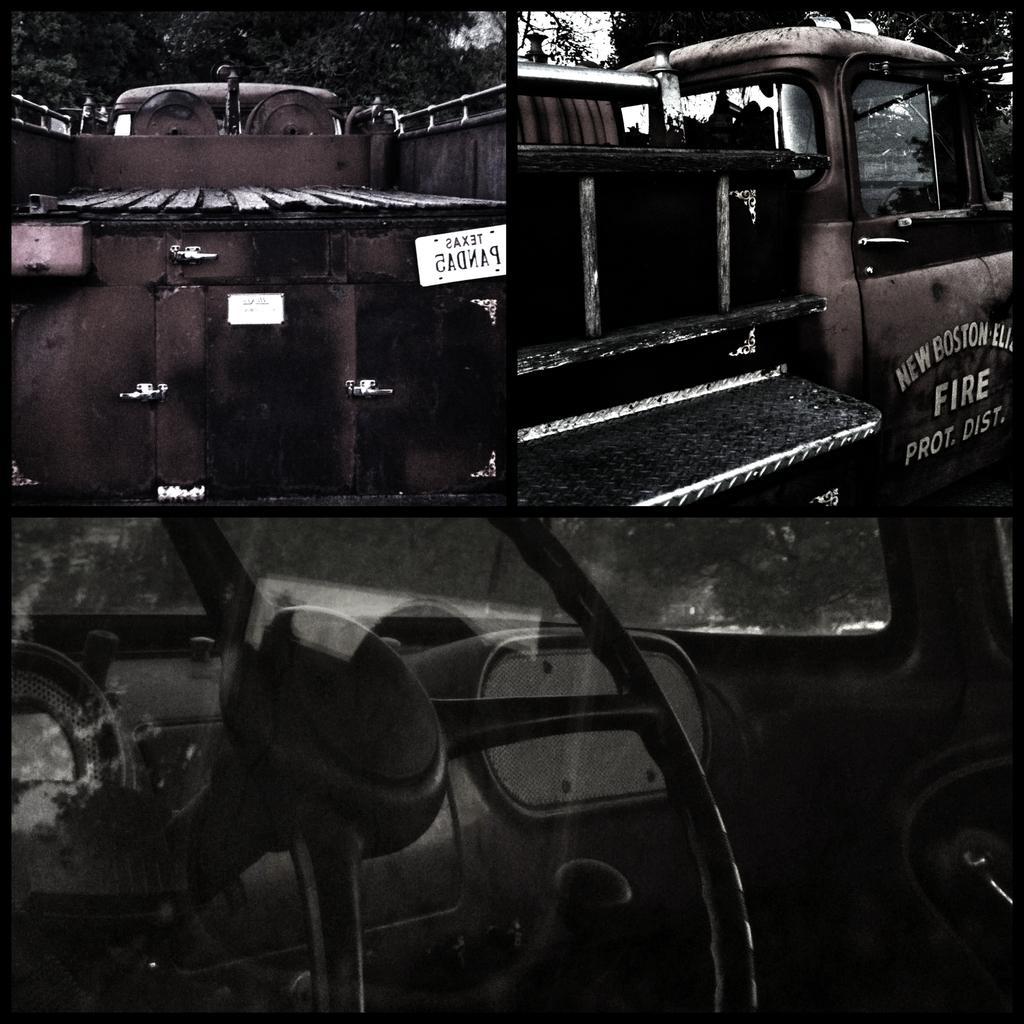In one or two sentences, can you explain what this image depicts? As we can see in the image in the front there are vehicles and in the background there are trees. 